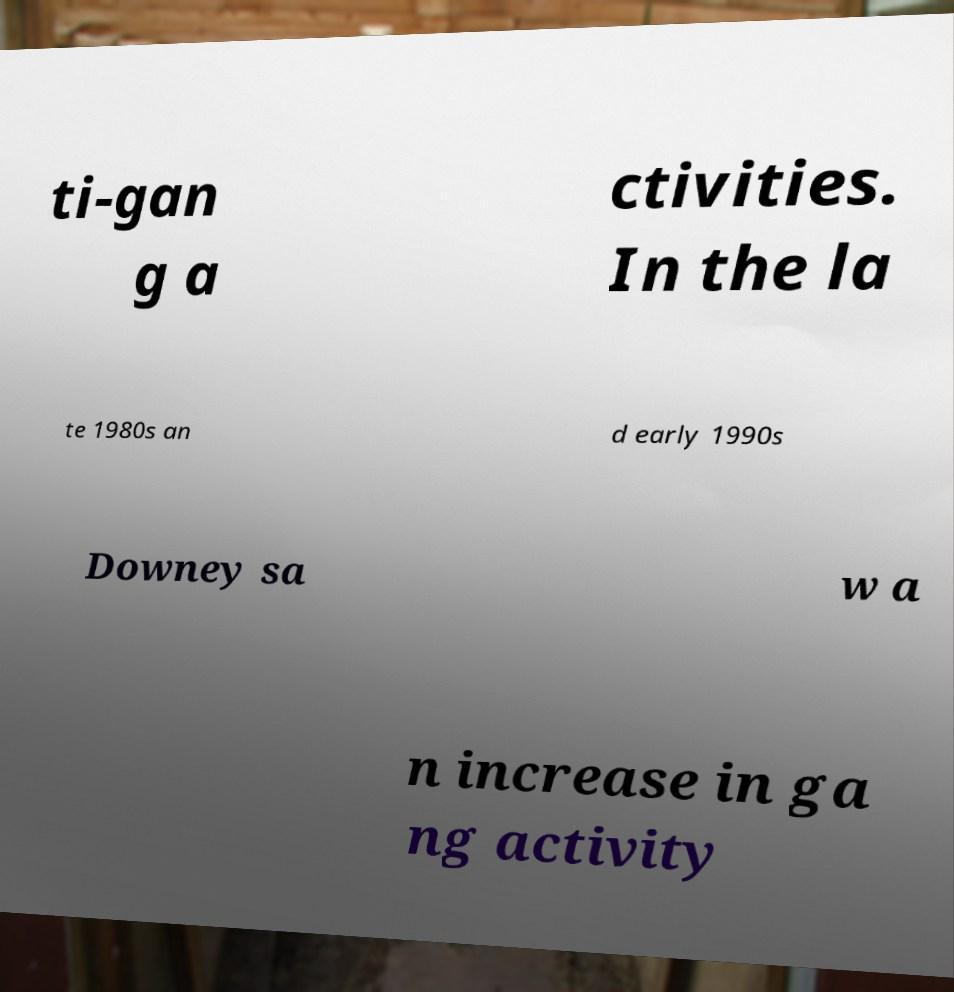There's text embedded in this image that I need extracted. Can you transcribe it verbatim? ti-gan g a ctivities. In the la te 1980s an d early 1990s Downey sa w a n increase in ga ng activity 